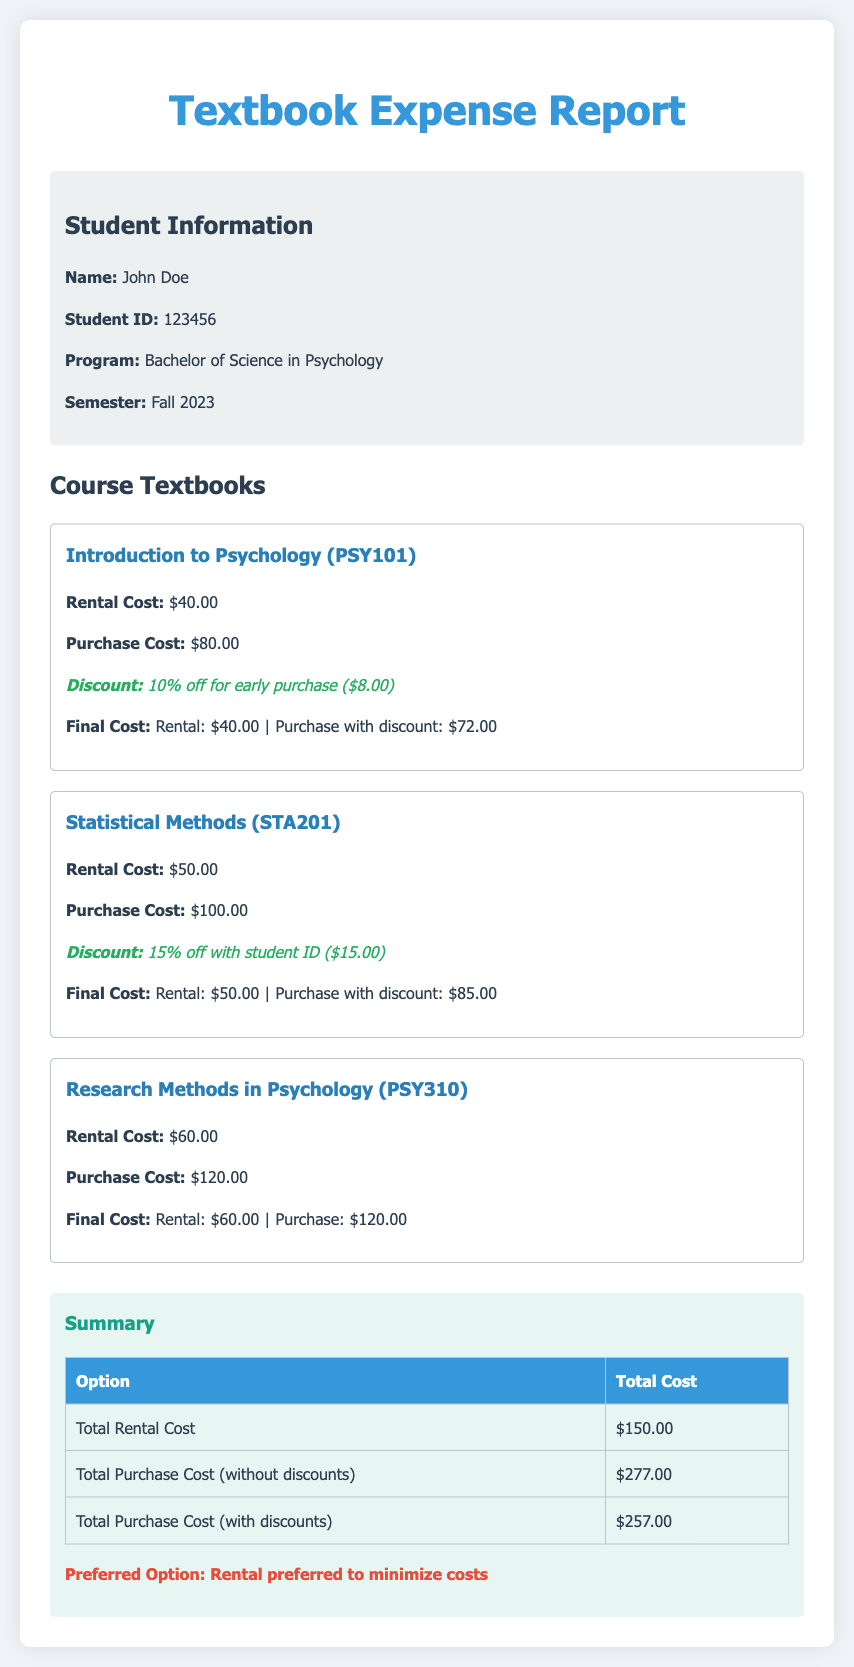What is the student's name? The student's name is stated in the student information section of the document.
Answer: John Doe What is the rental cost for Statistical Methods? The rental cost for Statistical Methods is mentioned in the course details.
Answer: $50.00 What discount is offered for early purchase of Introduction to Psychology? The discount for early purchase of Introduction to Psychology is detailed in its course section.
Answer: 10% off What is the final purchase cost with discount for Statistical Methods? The final purchase cost with discount for Statistical Methods is calculated in its course summary.
Answer: $85.00 How much is the total rental cost for all courses? The total rental cost is summarized in the report's summary section.
Answer: $150.00 What is the total purchase cost without discounts? The total purchase cost without discounts can be found in the summary of costs at the end of the document.
Answer: $277.00 What is the preferred option indicated in the summary? The preferred option is explicitly stated in the summary section.
Answer: Rental preferred to minimize costs What program is the student enrolled in? The program is provided in the student information section.
Answer: Bachelor of Science in Psychology 